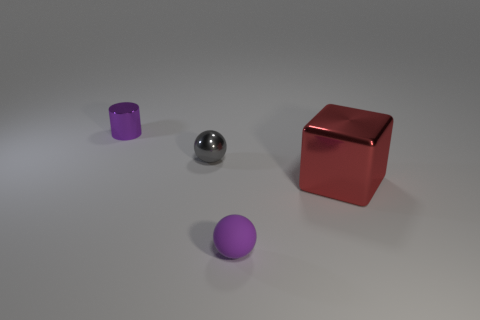Add 2 large shiny cubes. How many objects exist? 6 Subtract 1 blocks. How many blocks are left? 0 Subtract all purple spheres. How many spheres are left? 1 Subtract all cubes. How many objects are left? 3 Subtract all brown balls. How many green cubes are left? 0 Subtract all tiny purple shiny things. Subtract all gray objects. How many objects are left? 2 Add 3 balls. How many balls are left? 5 Add 2 purple rubber balls. How many purple rubber balls exist? 3 Subtract 0 brown balls. How many objects are left? 4 Subtract all cyan spheres. Subtract all purple cylinders. How many spheres are left? 2 